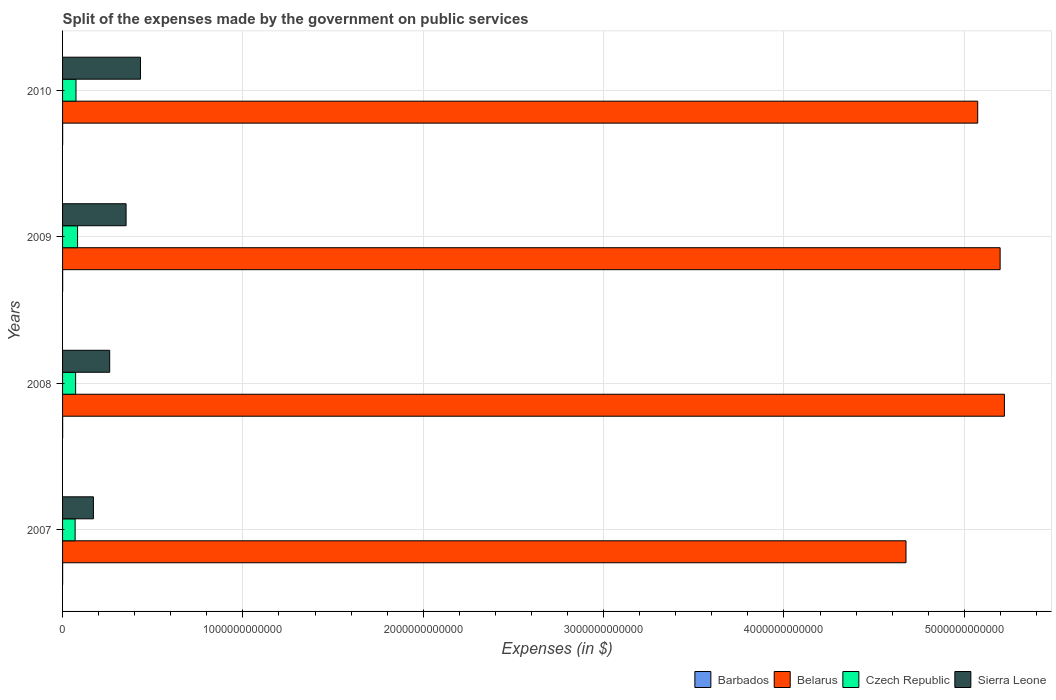How many different coloured bars are there?
Your response must be concise. 4. Are the number of bars on each tick of the Y-axis equal?
Keep it short and to the point. Yes. How many bars are there on the 4th tick from the top?
Offer a terse response. 4. How many bars are there on the 1st tick from the bottom?
Provide a succinct answer. 4. What is the label of the 4th group of bars from the top?
Offer a very short reply. 2007. What is the expenses made by the government on public services in Czech Republic in 2007?
Keep it short and to the point. 6.96e+1. Across all years, what is the maximum expenses made by the government on public services in Czech Republic?
Offer a very short reply. 8.32e+1. Across all years, what is the minimum expenses made by the government on public services in Belarus?
Make the answer very short. 4.68e+12. In which year was the expenses made by the government on public services in Belarus maximum?
Your response must be concise. 2008. In which year was the expenses made by the government on public services in Czech Republic minimum?
Your answer should be compact. 2007. What is the total expenses made by the government on public services in Belarus in the graph?
Your answer should be compact. 2.02e+13. What is the difference between the expenses made by the government on public services in Sierra Leone in 2007 and that in 2008?
Give a very brief answer. -9.03e+1. What is the difference between the expenses made by the government on public services in Czech Republic in 2010 and the expenses made by the government on public services in Sierra Leone in 2008?
Your answer should be very brief. -1.87e+11. What is the average expenses made by the government on public services in Barbados per year?
Offer a very short reply. 4.20e+08. In the year 2009, what is the difference between the expenses made by the government on public services in Sierra Leone and expenses made by the government on public services in Czech Republic?
Give a very brief answer. 2.69e+11. In how many years, is the expenses made by the government on public services in Barbados greater than 1600000000000 $?
Keep it short and to the point. 0. What is the ratio of the expenses made by the government on public services in Belarus in 2009 to that in 2010?
Make the answer very short. 1.02. Is the difference between the expenses made by the government on public services in Sierra Leone in 2008 and 2010 greater than the difference between the expenses made by the government on public services in Czech Republic in 2008 and 2010?
Offer a terse response. No. What is the difference between the highest and the second highest expenses made by the government on public services in Barbados?
Your answer should be very brief. 9.07e+06. What is the difference between the highest and the lowest expenses made by the government on public services in Sierra Leone?
Your response must be concise. 2.61e+11. In how many years, is the expenses made by the government on public services in Czech Republic greater than the average expenses made by the government on public services in Czech Republic taken over all years?
Provide a succinct answer. 1. Is it the case that in every year, the sum of the expenses made by the government on public services in Belarus and expenses made by the government on public services in Czech Republic is greater than the sum of expenses made by the government on public services in Sierra Leone and expenses made by the government on public services in Barbados?
Give a very brief answer. Yes. What does the 2nd bar from the top in 2008 represents?
Your response must be concise. Czech Republic. What does the 2nd bar from the bottom in 2007 represents?
Your response must be concise. Belarus. What is the difference between two consecutive major ticks on the X-axis?
Your answer should be compact. 1.00e+12. Are the values on the major ticks of X-axis written in scientific E-notation?
Your answer should be compact. No. Does the graph contain grids?
Offer a very short reply. Yes. Where does the legend appear in the graph?
Your response must be concise. Bottom right. How many legend labels are there?
Provide a succinct answer. 4. How are the legend labels stacked?
Offer a terse response. Horizontal. What is the title of the graph?
Provide a succinct answer. Split of the expenses made by the government on public services. What is the label or title of the X-axis?
Offer a very short reply. Expenses (in $). What is the Expenses (in $) in Barbados in 2007?
Make the answer very short. 3.67e+08. What is the Expenses (in $) of Belarus in 2007?
Offer a very short reply. 4.68e+12. What is the Expenses (in $) in Czech Republic in 2007?
Your answer should be compact. 6.96e+1. What is the Expenses (in $) in Sierra Leone in 2007?
Provide a short and direct response. 1.71e+11. What is the Expenses (in $) in Barbados in 2008?
Offer a terse response. 4.35e+08. What is the Expenses (in $) in Belarus in 2008?
Offer a very short reply. 5.22e+12. What is the Expenses (in $) in Czech Republic in 2008?
Provide a succinct answer. 7.24e+1. What is the Expenses (in $) of Sierra Leone in 2008?
Offer a terse response. 2.61e+11. What is the Expenses (in $) in Barbados in 2009?
Give a very brief answer. 4.44e+08. What is the Expenses (in $) in Belarus in 2009?
Provide a short and direct response. 5.20e+12. What is the Expenses (in $) in Czech Republic in 2009?
Ensure brevity in your answer.  8.32e+1. What is the Expenses (in $) in Sierra Leone in 2009?
Your answer should be very brief. 3.52e+11. What is the Expenses (in $) in Barbados in 2010?
Keep it short and to the point. 4.35e+08. What is the Expenses (in $) of Belarus in 2010?
Offer a very short reply. 5.07e+12. What is the Expenses (in $) of Czech Republic in 2010?
Give a very brief answer. 7.45e+1. What is the Expenses (in $) of Sierra Leone in 2010?
Provide a succinct answer. 4.32e+11. Across all years, what is the maximum Expenses (in $) of Barbados?
Your response must be concise. 4.44e+08. Across all years, what is the maximum Expenses (in $) of Belarus?
Offer a terse response. 5.22e+12. Across all years, what is the maximum Expenses (in $) in Czech Republic?
Provide a succinct answer. 8.32e+1. Across all years, what is the maximum Expenses (in $) of Sierra Leone?
Provide a short and direct response. 4.32e+11. Across all years, what is the minimum Expenses (in $) in Barbados?
Offer a very short reply. 3.67e+08. Across all years, what is the minimum Expenses (in $) of Belarus?
Your response must be concise. 4.68e+12. Across all years, what is the minimum Expenses (in $) of Czech Republic?
Make the answer very short. 6.96e+1. Across all years, what is the minimum Expenses (in $) of Sierra Leone?
Offer a very short reply. 1.71e+11. What is the total Expenses (in $) of Barbados in the graph?
Provide a succinct answer. 1.68e+09. What is the total Expenses (in $) of Belarus in the graph?
Make the answer very short. 2.02e+13. What is the total Expenses (in $) in Czech Republic in the graph?
Provide a succinct answer. 3.00e+11. What is the total Expenses (in $) of Sierra Leone in the graph?
Provide a succinct answer. 1.22e+12. What is the difference between the Expenses (in $) of Barbados in 2007 and that in 2008?
Make the answer very short. -6.75e+07. What is the difference between the Expenses (in $) of Belarus in 2007 and that in 2008?
Give a very brief answer. -5.46e+11. What is the difference between the Expenses (in $) in Czech Republic in 2007 and that in 2008?
Make the answer very short. -2.80e+09. What is the difference between the Expenses (in $) in Sierra Leone in 2007 and that in 2008?
Make the answer very short. -9.03e+1. What is the difference between the Expenses (in $) in Barbados in 2007 and that in 2009?
Your response must be concise. -7.74e+07. What is the difference between the Expenses (in $) in Belarus in 2007 and that in 2009?
Provide a succinct answer. -5.22e+11. What is the difference between the Expenses (in $) of Czech Republic in 2007 and that in 2009?
Keep it short and to the point. -1.35e+1. What is the difference between the Expenses (in $) of Sierra Leone in 2007 and that in 2009?
Your answer should be very brief. -1.81e+11. What is the difference between the Expenses (in $) in Barbados in 2007 and that in 2010?
Keep it short and to the point. -6.83e+07. What is the difference between the Expenses (in $) in Belarus in 2007 and that in 2010?
Give a very brief answer. -3.98e+11. What is the difference between the Expenses (in $) of Czech Republic in 2007 and that in 2010?
Give a very brief answer. -4.86e+09. What is the difference between the Expenses (in $) of Sierra Leone in 2007 and that in 2010?
Keep it short and to the point. -2.61e+11. What is the difference between the Expenses (in $) in Barbados in 2008 and that in 2009?
Give a very brief answer. -9.82e+06. What is the difference between the Expenses (in $) of Belarus in 2008 and that in 2009?
Offer a very short reply. 2.37e+1. What is the difference between the Expenses (in $) of Czech Republic in 2008 and that in 2009?
Offer a terse response. -1.07e+1. What is the difference between the Expenses (in $) of Sierra Leone in 2008 and that in 2009?
Ensure brevity in your answer.  -9.09e+1. What is the difference between the Expenses (in $) in Barbados in 2008 and that in 2010?
Give a very brief answer. -7.51e+05. What is the difference between the Expenses (in $) of Belarus in 2008 and that in 2010?
Give a very brief answer. 1.48e+11. What is the difference between the Expenses (in $) in Czech Republic in 2008 and that in 2010?
Make the answer very short. -2.06e+09. What is the difference between the Expenses (in $) in Sierra Leone in 2008 and that in 2010?
Provide a short and direct response. -1.71e+11. What is the difference between the Expenses (in $) in Barbados in 2009 and that in 2010?
Offer a terse response. 9.07e+06. What is the difference between the Expenses (in $) in Belarus in 2009 and that in 2010?
Offer a very short reply. 1.24e+11. What is the difference between the Expenses (in $) of Czech Republic in 2009 and that in 2010?
Make the answer very short. 8.68e+09. What is the difference between the Expenses (in $) of Sierra Leone in 2009 and that in 2010?
Provide a succinct answer. -7.99e+1. What is the difference between the Expenses (in $) of Barbados in 2007 and the Expenses (in $) of Belarus in 2008?
Keep it short and to the point. -5.22e+12. What is the difference between the Expenses (in $) of Barbados in 2007 and the Expenses (in $) of Czech Republic in 2008?
Offer a terse response. -7.20e+1. What is the difference between the Expenses (in $) in Barbados in 2007 and the Expenses (in $) in Sierra Leone in 2008?
Give a very brief answer. -2.61e+11. What is the difference between the Expenses (in $) in Belarus in 2007 and the Expenses (in $) in Czech Republic in 2008?
Your answer should be very brief. 4.60e+12. What is the difference between the Expenses (in $) in Belarus in 2007 and the Expenses (in $) in Sierra Leone in 2008?
Your answer should be compact. 4.42e+12. What is the difference between the Expenses (in $) in Czech Republic in 2007 and the Expenses (in $) in Sierra Leone in 2008?
Your answer should be very brief. -1.92e+11. What is the difference between the Expenses (in $) of Barbados in 2007 and the Expenses (in $) of Belarus in 2009?
Your response must be concise. -5.20e+12. What is the difference between the Expenses (in $) in Barbados in 2007 and the Expenses (in $) in Czech Republic in 2009?
Keep it short and to the point. -8.28e+1. What is the difference between the Expenses (in $) of Barbados in 2007 and the Expenses (in $) of Sierra Leone in 2009?
Offer a very short reply. -3.52e+11. What is the difference between the Expenses (in $) of Belarus in 2007 and the Expenses (in $) of Czech Republic in 2009?
Your answer should be very brief. 4.59e+12. What is the difference between the Expenses (in $) in Belarus in 2007 and the Expenses (in $) in Sierra Leone in 2009?
Provide a short and direct response. 4.32e+12. What is the difference between the Expenses (in $) in Czech Republic in 2007 and the Expenses (in $) in Sierra Leone in 2009?
Provide a short and direct response. -2.83e+11. What is the difference between the Expenses (in $) in Barbados in 2007 and the Expenses (in $) in Belarus in 2010?
Ensure brevity in your answer.  -5.07e+12. What is the difference between the Expenses (in $) of Barbados in 2007 and the Expenses (in $) of Czech Republic in 2010?
Give a very brief answer. -7.41e+1. What is the difference between the Expenses (in $) of Barbados in 2007 and the Expenses (in $) of Sierra Leone in 2010?
Ensure brevity in your answer.  -4.32e+11. What is the difference between the Expenses (in $) in Belarus in 2007 and the Expenses (in $) in Czech Republic in 2010?
Offer a terse response. 4.60e+12. What is the difference between the Expenses (in $) in Belarus in 2007 and the Expenses (in $) in Sierra Leone in 2010?
Give a very brief answer. 4.24e+12. What is the difference between the Expenses (in $) of Czech Republic in 2007 and the Expenses (in $) of Sierra Leone in 2010?
Make the answer very short. -3.62e+11. What is the difference between the Expenses (in $) in Barbados in 2008 and the Expenses (in $) in Belarus in 2009?
Provide a succinct answer. -5.20e+12. What is the difference between the Expenses (in $) of Barbados in 2008 and the Expenses (in $) of Czech Republic in 2009?
Ensure brevity in your answer.  -8.27e+1. What is the difference between the Expenses (in $) in Barbados in 2008 and the Expenses (in $) in Sierra Leone in 2009?
Your answer should be compact. -3.52e+11. What is the difference between the Expenses (in $) of Belarus in 2008 and the Expenses (in $) of Czech Republic in 2009?
Offer a terse response. 5.14e+12. What is the difference between the Expenses (in $) of Belarus in 2008 and the Expenses (in $) of Sierra Leone in 2009?
Provide a succinct answer. 4.87e+12. What is the difference between the Expenses (in $) of Czech Republic in 2008 and the Expenses (in $) of Sierra Leone in 2009?
Give a very brief answer. -2.80e+11. What is the difference between the Expenses (in $) of Barbados in 2008 and the Expenses (in $) of Belarus in 2010?
Your answer should be compact. -5.07e+12. What is the difference between the Expenses (in $) in Barbados in 2008 and the Expenses (in $) in Czech Republic in 2010?
Your response must be concise. -7.40e+1. What is the difference between the Expenses (in $) of Barbados in 2008 and the Expenses (in $) of Sierra Leone in 2010?
Your answer should be compact. -4.32e+11. What is the difference between the Expenses (in $) of Belarus in 2008 and the Expenses (in $) of Czech Republic in 2010?
Make the answer very short. 5.15e+12. What is the difference between the Expenses (in $) of Belarus in 2008 and the Expenses (in $) of Sierra Leone in 2010?
Your response must be concise. 4.79e+12. What is the difference between the Expenses (in $) in Czech Republic in 2008 and the Expenses (in $) in Sierra Leone in 2010?
Keep it short and to the point. -3.60e+11. What is the difference between the Expenses (in $) of Barbados in 2009 and the Expenses (in $) of Belarus in 2010?
Provide a short and direct response. -5.07e+12. What is the difference between the Expenses (in $) in Barbados in 2009 and the Expenses (in $) in Czech Republic in 2010?
Make the answer very short. -7.40e+1. What is the difference between the Expenses (in $) of Barbados in 2009 and the Expenses (in $) of Sierra Leone in 2010?
Give a very brief answer. -4.32e+11. What is the difference between the Expenses (in $) of Belarus in 2009 and the Expenses (in $) of Czech Republic in 2010?
Offer a very short reply. 5.12e+12. What is the difference between the Expenses (in $) of Belarus in 2009 and the Expenses (in $) of Sierra Leone in 2010?
Your answer should be compact. 4.77e+12. What is the difference between the Expenses (in $) of Czech Republic in 2009 and the Expenses (in $) of Sierra Leone in 2010?
Offer a terse response. -3.49e+11. What is the average Expenses (in $) of Barbados per year?
Keep it short and to the point. 4.20e+08. What is the average Expenses (in $) in Belarus per year?
Offer a very short reply. 5.04e+12. What is the average Expenses (in $) of Czech Republic per year?
Give a very brief answer. 7.49e+1. What is the average Expenses (in $) in Sierra Leone per year?
Provide a short and direct response. 3.04e+11. In the year 2007, what is the difference between the Expenses (in $) in Barbados and Expenses (in $) in Belarus?
Give a very brief answer. -4.68e+12. In the year 2007, what is the difference between the Expenses (in $) of Barbados and Expenses (in $) of Czech Republic?
Give a very brief answer. -6.92e+1. In the year 2007, what is the difference between the Expenses (in $) of Barbados and Expenses (in $) of Sierra Leone?
Provide a succinct answer. -1.71e+11. In the year 2007, what is the difference between the Expenses (in $) in Belarus and Expenses (in $) in Czech Republic?
Your response must be concise. 4.61e+12. In the year 2007, what is the difference between the Expenses (in $) of Belarus and Expenses (in $) of Sierra Leone?
Provide a succinct answer. 4.51e+12. In the year 2007, what is the difference between the Expenses (in $) of Czech Republic and Expenses (in $) of Sierra Leone?
Keep it short and to the point. -1.01e+11. In the year 2008, what is the difference between the Expenses (in $) of Barbados and Expenses (in $) of Belarus?
Give a very brief answer. -5.22e+12. In the year 2008, what is the difference between the Expenses (in $) of Barbados and Expenses (in $) of Czech Republic?
Your response must be concise. -7.20e+1. In the year 2008, what is the difference between the Expenses (in $) of Barbados and Expenses (in $) of Sierra Leone?
Your response must be concise. -2.61e+11. In the year 2008, what is the difference between the Expenses (in $) of Belarus and Expenses (in $) of Czech Republic?
Your response must be concise. 5.15e+12. In the year 2008, what is the difference between the Expenses (in $) in Belarus and Expenses (in $) in Sierra Leone?
Keep it short and to the point. 4.96e+12. In the year 2008, what is the difference between the Expenses (in $) of Czech Republic and Expenses (in $) of Sierra Leone?
Your response must be concise. -1.89e+11. In the year 2009, what is the difference between the Expenses (in $) in Barbados and Expenses (in $) in Belarus?
Ensure brevity in your answer.  -5.20e+12. In the year 2009, what is the difference between the Expenses (in $) in Barbados and Expenses (in $) in Czech Republic?
Ensure brevity in your answer.  -8.27e+1. In the year 2009, what is the difference between the Expenses (in $) of Barbados and Expenses (in $) of Sierra Leone?
Your response must be concise. -3.52e+11. In the year 2009, what is the difference between the Expenses (in $) of Belarus and Expenses (in $) of Czech Republic?
Provide a short and direct response. 5.12e+12. In the year 2009, what is the difference between the Expenses (in $) of Belarus and Expenses (in $) of Sierra Leone?
Ensure brevity in your answer.  4.85e+12. In the year 2009, what is the difference between the Expenses (in $) in Czech Republic and Expenses (in $) in Sierra Leone?
Your answer should be very brief. -2.69e+11. In the year 2010, what is the difference between the Expenses (in $) of Barbados and Expenses (in $) of Belarus?
Provide a short and direct response. -5.07e+12. In the year 2010, what is the difference between the Expenses (in $) in Barbados and Expenses (in $) in Czech Republic?
Keep it short and to the point. -7.40e+1. In the year 2010, what is the difference between the Expenses (in $) of Barbados and Expenses (in $) of Sierra Leone?
Offer a terse response. -4.32e+11. In the year 2010, what is the difference between the Expenses (in $) of Belarus and Expenses (in $) of Czech Republic?
Offer a terse response. 5.00e+12. In the year 2010, what is the difference between the Expenses (in $) in Belarus and Expenses (in $) in Sierra Leone?
Offer a very short reply. 4.64e+12. In the year 2010, what is the difference between the Expenses (in $) in Czech Republic and Expenses (in $) in Sierra Leone?
Keep it short and to the point. -3.58e+11. What is the ratio of the Expenses (in $) in Barbados in 2007 to that in 2008?
Ensure brevity in your answer.  0.84. What is the ratio of the Expenses (in $) of Belarus in 2007 to that in 2008?
Your answer should be very brief. 0.9. What is the ratio of the Expenses (in $) in Czech Republic in 2007 to that in 2008?
Offer a very short reply. 0.96. What is the ratio of the Expenses (in $) in Sierra Leone in 2007 to that in 2008?
Keep it short and to the point. 0.65. What is the ratio of the Expenses (in $) in Barbados in 2007 to that in 2009?
Provide a succinct answer. 0.83. What is the ratio of the Expenses (in $) in Belarus in 2007 to that in 2009?
Your response must be concise. 0.9. What is the ratio of the Expenses (in $) of Czech Republic in 2007 to that in 2009?
Ensure brevity in your answer.  0.84. What is the ratio of the Expenses (in $) in Sierra Leone in 2007 to that in 2009?
Give a very brief answer. 0.49. What is the ratio of the Expenses (in $) of Barbados in 2007 to that in 2010?
Provide a short and direct response. 0.84. What is the ratio of the Expenses (in $) of Belarus in 2007 to that in 2010?
Offer a terse response. 0.92. What is the ratio of the Expenses (in $) of Czech Republic in 2007 to that in 2010?
Ensure brevity in your answer.  0.93. What is the ratio of the Expenses (in $) in Sierra Leone in 2007 to that in 2010?
Keep it short and to the point. 0.4. What is the ratio of the Expenses (in $) of Barbados in 2008 to that in 2009?
Offer a terse response. 0.98. What is the ratio of the Expenses (in $) in Belarus in 2008 to that in 2009?
Your response must be concise. 1. What is the ratio of the Expenses (in $) in Czech Republic in 2008 to that in 2009?
Your answer should be compact. 0.87. What is the ratio of the Expenses (in $) of Sierra Leone in 2008 to that in 2009?
Provide a succinct answer. 0.74. What is the ratio of the Expenses (in $) of Belarus in 2008 to that in 2010?
Keep it short and to the point. 1.03. What is the ratio of the Expenses (in $) of Czech Republic in 2008 to that in 2010?
Give a very brief answer. 0.97. What is the ratio of the Expenses (in $) in Sierra Leone in 2008 to that in 2010?
Offer a terse response. 0.6. What is the ratio of the Expenses (in $) in Barbados in 2009 to that in 2010?
Make the answer very short. 1.02. What is the ratio of the Expenses (in $) of Belarus in 2009 to that in 2010?
Your answer should be compact. 1.02. What is the ratio of the Expenses (in $) in Czech Republic in 2009 to that in 2010?
Provide a succinct answer. 1.12. What is the ratio of the Expenses (in $) in Sierra Leone in 2009 to that in 2010?
Your answer should be very brief. 0.82. What is the difference between the highest and the second highest Expenses (in $) in Barbados?
Provide a short and direct response. 9.07e+06. What is the difference between the highest and the second highest Expenses (in $) of Belarus?
Provide a short and direct response. 2.37e+1. What is the difference between the highest and the second highest Expenses (in $) in Czech Republic?
Keep it short and to the point. 8.68e+09. What is the difference between the highest and the second highest Expenses (in $) of Sierra Leone?
Provide a succinct answer. 7.99e+1. What is the difference between the highest and the lowest Expenses (in $) of Barbados?
Ensure brevity in your answer.  7.74e+07. What is the difference between the highest and the lowest Expenses (in $) in Belarus?
Your answer should be compact. 5.46e+11. What is the difference between the highest and the lowest Expenses (in $) of Czech Republic?
Give a very brief answer. 1.35e+1. What is the difference between the highest and the lowest Expenses (in $) in Sierra Leone?
Give a very brief answer. 2.61e+11. 